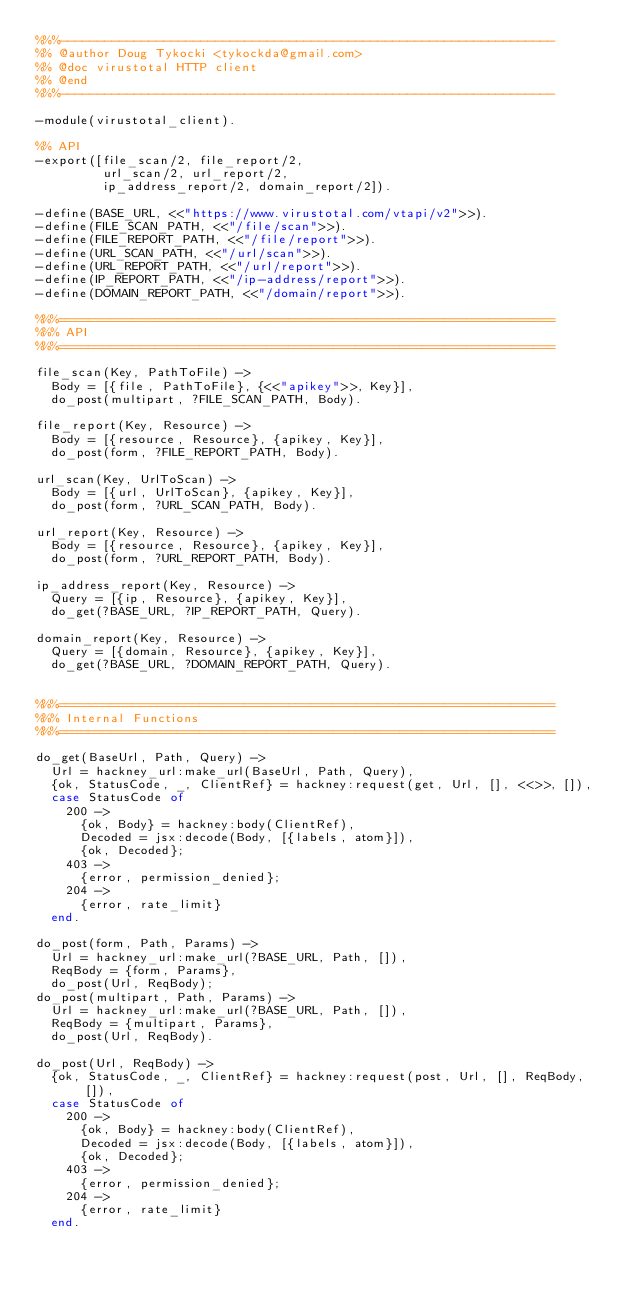Convert code to text. <code><loc_0><loc_0><loc_500><loc_500><_Erlang_>%%%-------------------------------------------------------------------
%% @author Doug Tykocki <tykockda@gmail.com>
%% @doc virustotal HTTP client
%% @end
%%%-------------------------------------------------------------------

-module(virustotal_client).

%% API
-export([file_scan/2, file_report/2,
         url_scan/2, url_report/2,
         ip_address_report/2, domain_report/2]).

-define(BASE_URL, <<"https://www.virustotal.com/vtapi/v2">>).
-define(FILE_SCAN_PATH, <<"/file/scan">>).
-define(FILE_REPORT_PATH, <<"/file/report">>).
-define(URL_SCAN_PATH, <<"/url/scan">>).
-define(URL_REPORT_PATH, <<"/url/report">>).
-define(IP_REPORT_PATH, <<"/ip-address/report">>).
-define(DOMAIN_REPORT_PATH, <<"/domain/report">>).

%%%===================================================================
%%% API
%%%===================================================================

file_scan(Key, PathToFile) ->
  Body = [{file, PathToFile}, {<<"apikey">>, Key}],
  do_post(multipart, ?FILE_SCAN_PATH, Body).

file_report(Key, Resource) ->
  Body = [{resource, Resource}, {apikey, Key}],
  do_post(form, ?FILE_REPORT_PATH, Body).

url_scan(Key, UrlToScan) ->
  Body = [{url, UrlToScan}, {apikey, Key}],
  do_post(form, ?URL_SCAN_PATH, Body).

url_report(Key, Resource) ->
  Body = [{resource, Resource}, {apikey, Key}],
  do_post(form, ?URL_REPORT_PATH, Body).

ip_address_report(Key, Resource) ->
  Query = [{ip, Resource}, {apikey, Key}],
  do_get(?BASE_URL, ?IP_REPORT_PATH, Query).

domain_report(Key, Resource) ->
  Query = [{domain, Resource}, {apikey, Key}],
  do_get(?BASE_URL, ?DOMAIN_REPORT_PATH, Query).


%%%===================================================================
%%% Internal Functions
%%%===================================================================

do_get(BaseUrl, Path, Query) ->
  Url = hackney_url:make_url(BaseUrl, Path, Query),
  {ok, StatusCode, _, ClientRef} = hackney:request(get, Url, [], <<>>, []),
  case StatusCode of
    200 ->
      {ok, Body} = hackney:body(ClientRef),
      Decoded = jsx:decode(Body, [{labels, atom}]),
      {ok, Decoded};
    403 ->
      {error, permission_denied};
    204 ->
      {error, rate_limit}
  end.

do_post(form, Path, Params) ->
  Url = hackney_url:make_url(?BASE_URL, Path, []),
  ReqBody = {form, Params},
  do_post(Url, ReqBody);
do_post(multipart, Path, Params) ->
  Url = hackney_url:make_url(?BASE_URL, Path, []),
  ReqBody = {multipart, Params},
  do_post(Url, ReqBody).

do_post(Url, ReqBody) ->
  {ok, StatusCode, _, ClientRef} = hackney:request(post, Url, [], ReqBody, []),
  case StatusCode of
    200 ->
      {ok, Body} = hackney:body(ClientRef),
      Decoded = jsx:decode(Body, [{labels, atom}]),
      {ok, Decoded};
    403 ->
      {error, permission_denied};
    204 ->
      {error, rate_limit}
  end.
</code> 